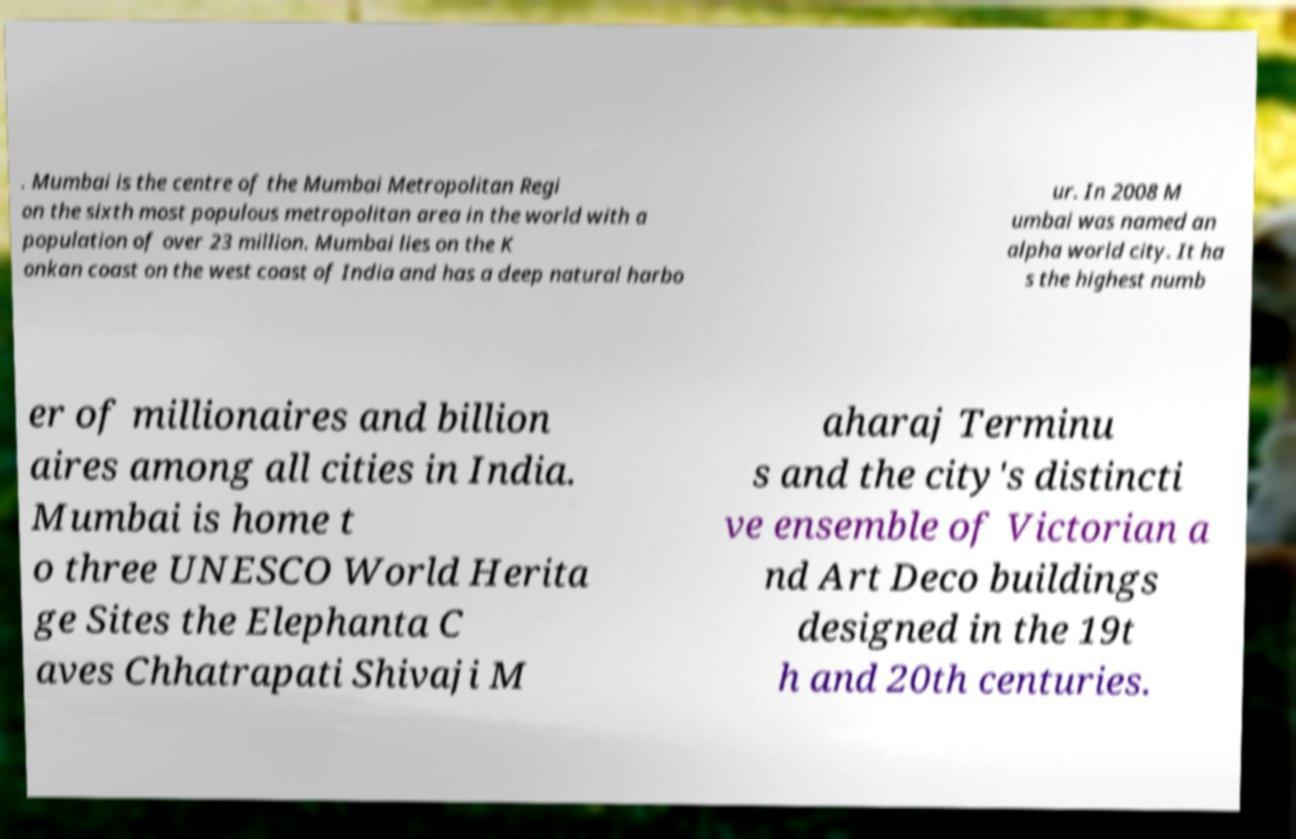Can you accurately transcribe the text from the provided image for me? . Mumbai is the centre of the Mumbai Metropolitan Regi on the sixth most populous metropolitan area in the world with a population of over 23 million. Mumbai lies on the K onkan coast on the west coast of India and has a deep natural harbo ur. In 2008 M umbai was named an alpha world city. It ha s the highest numb er of millionaires and billion aires among all cities in India. Mumbai is home t o three UNESCO World Herita ge Sites the Elephanta C aves Chhatrapati Shivaji M aharaj Terminu s and the city's distincti ve ensemble of Victorian a nd Art Deco buildings designed in the 19t h and 20th centuries. 